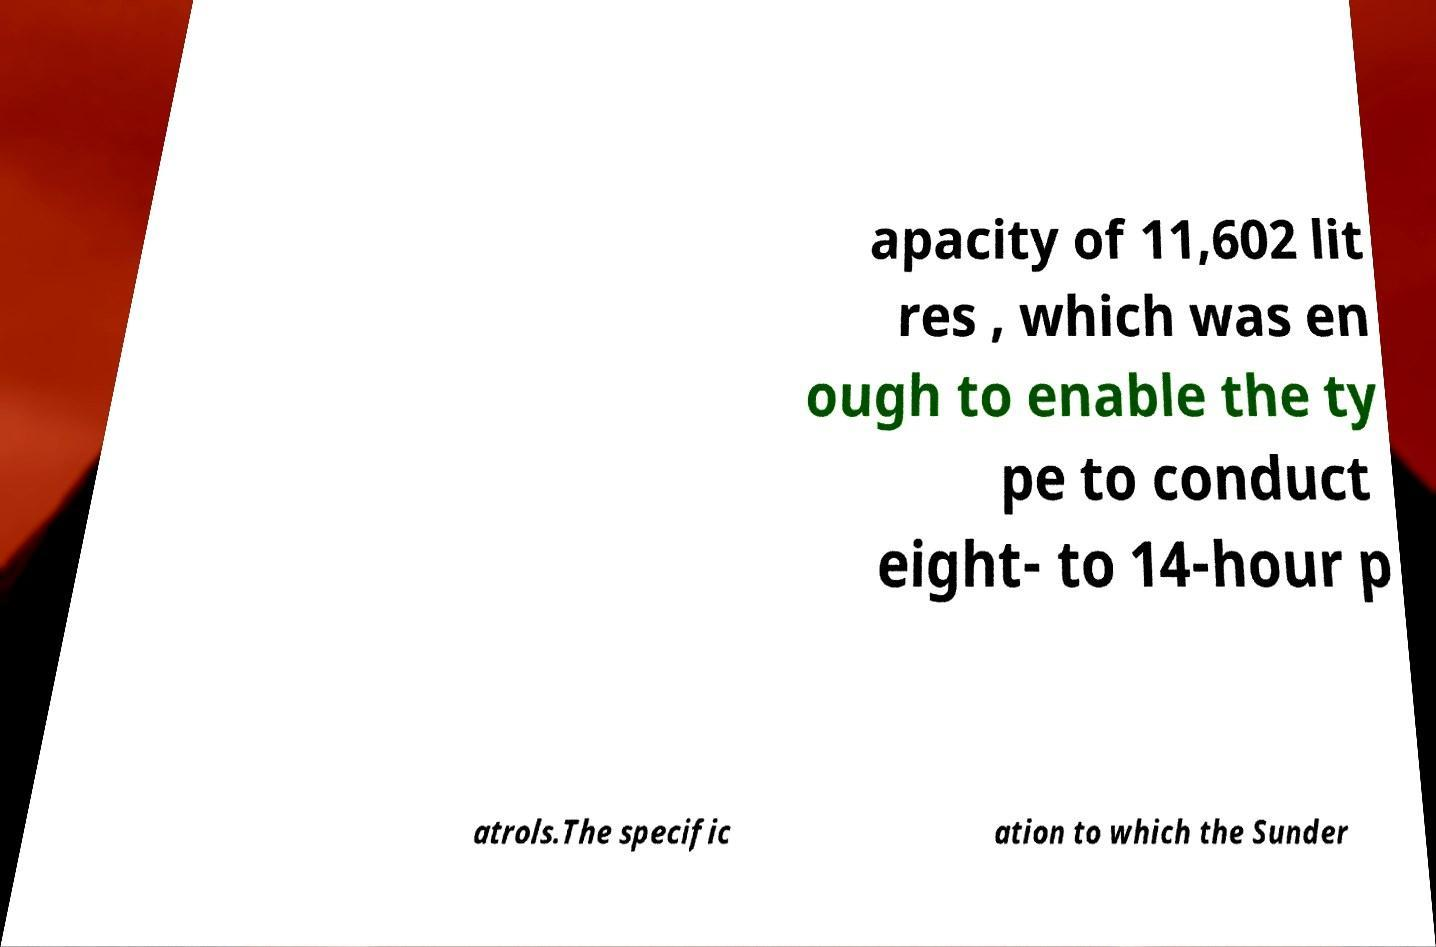I need the written content from this picture converted into text. Can you do that? apacity of 11,602 lit res , which was en ough to enable the ty pe to conduct eight- to 14-hour p atrols.The specific ation to which the Sunder 